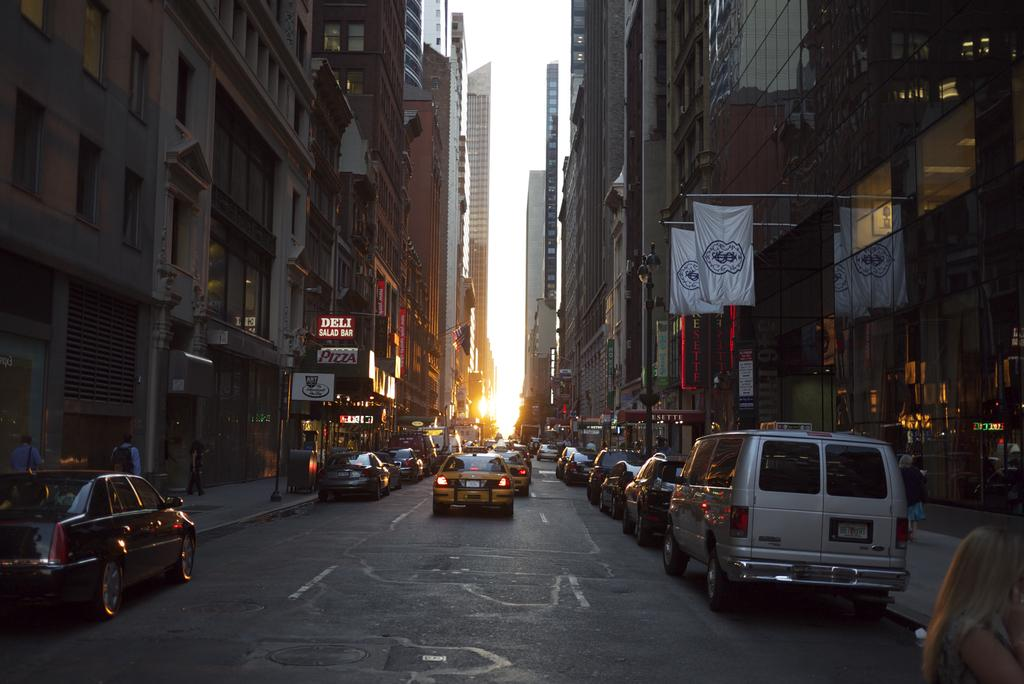What can be seen on the road in the image? There are vehicles on the road in the image. What is visible on either side of the road? There are buildings on either side of the road in the image. Can you describe the woman in the image? There is a woman standing in the right bottom corner of the image. What type of food is the stranger eating in the image? There is no stranger present in the image, and therefore no food can be observed. What is the rate of the vehicles passing by in the image? The provided facts do not mention the speed of the vehicles, so it is not possible to determine the rate at which they are passing by. 